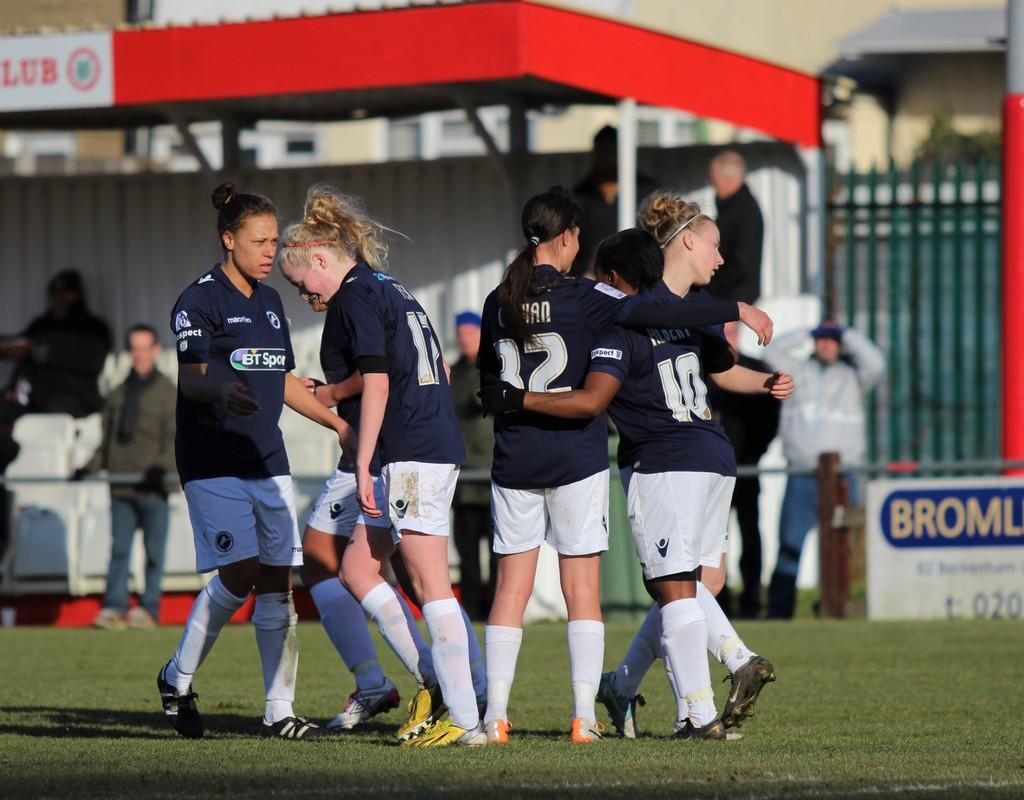What is happening in the image? There are players in the image, and they are on a ground. Can you describe the setting of the image? The players are on a ground, and there are people in the background of the image. Where are the people in the background located? The people in the background are standing under a shed. How is the background of the image depicted? The background is blurred. What type of vase can be seen on the ground in the image? There is no vase present in the image; it features players on a ground and people in the background. 